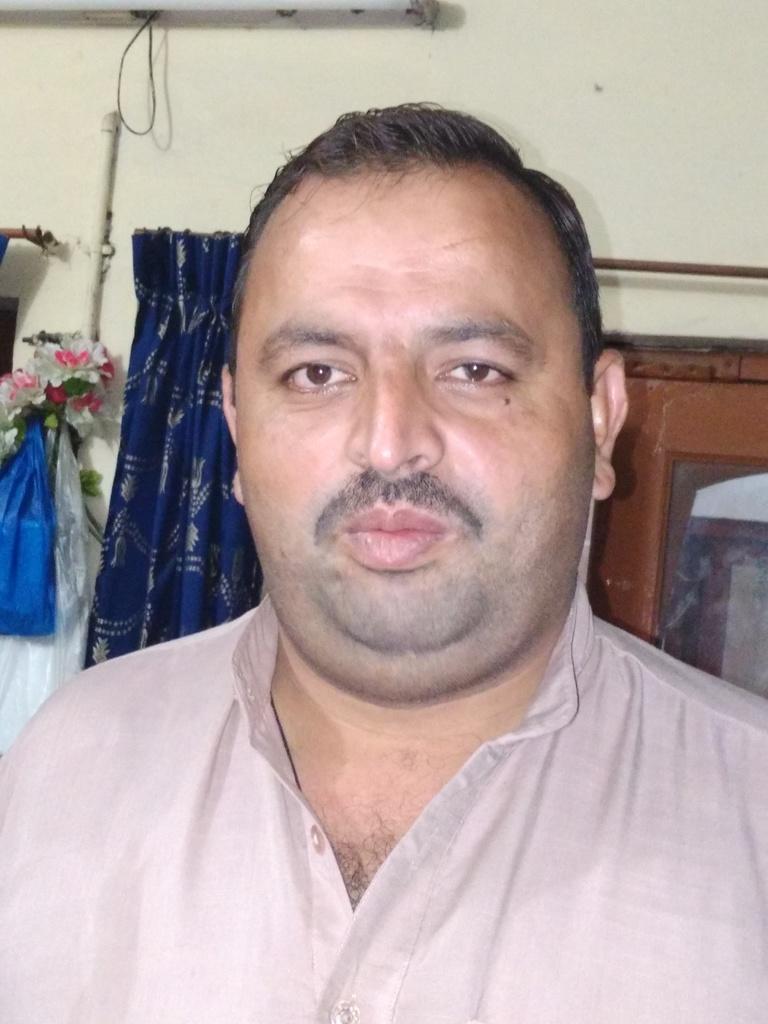In one or two sentences, can you explain what this image depicts? In the middle of the image we can see a man, behind to him we can find few plastic covers, flower vase, curtains and a light on the wall. 